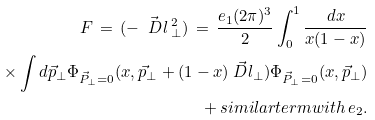Convert formula to latex. <formula><loc_0><loc_0><loc_500><loc_500>F \, = \, ( - \vec { \ D l } { \, } _ { \bot } ^ { 2 } ) \, = \, \frac { e _ { 1 } ( 2 \pi ) ^ { 3 } } { 2 } \int _ { 0 } ^ { 1 } \frac { d x } { x ( 1 - x ) } \\ \times \int d \vec { p } _ { \bot } \Phi _ { \vec { P } _ { \bot } = 0 } ( x , \vec { p } _ { \bot } + ( 1 - x ) \vec { \ D l } _ { \bot } ) \Phi _ { \vec { P } _ { \bot } = 0 } ( x , \vec { p } _ { \bot } ) \\ + \, s i m i l a r t e r m w i t h \, e _ { 2 } .</formula> 